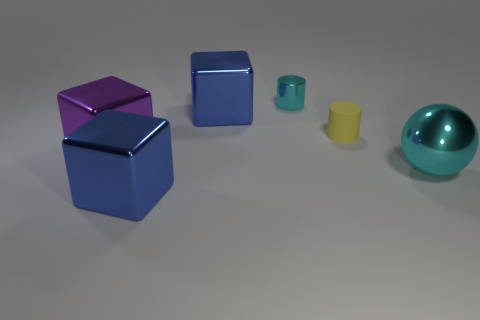Is the number of big shiny cubes that are in front of the large ball less than the number of tiny cylinders?
Offer a very short reply. Yes. The cyan shiny object behind the cyan shiny ball has what shape?
Provide a succinct answer. Cylinder. There is a purple metal thing; is it the same size as the blue thing that is behind the large purple shiny cube?
Keep it short and to the point. Yes. Are there any small things made of the same material as the sphere?
Keep it short and to the point. Yes. What number of blocks are either metallic objects or matte things?
Make the answer very short. 3. There is a blue cube that is in front of the big cyan thing; are there any big purple shiny things right of it?
Offer a very short reply. No. Are there fewer cyan objects than cyan cylinders?
Make the answer very short. No. How many other yellow rubber objects are the same shape as the yellow thing?
Provide a succinct answer. 0. What number of green things are small cylinders or spheres?
Keep it short and to the point. 0. How big is the blue metallic cube that is in front of the yellow object that is in front of the cyan cylinder?
Your answer should be compact. Large. 